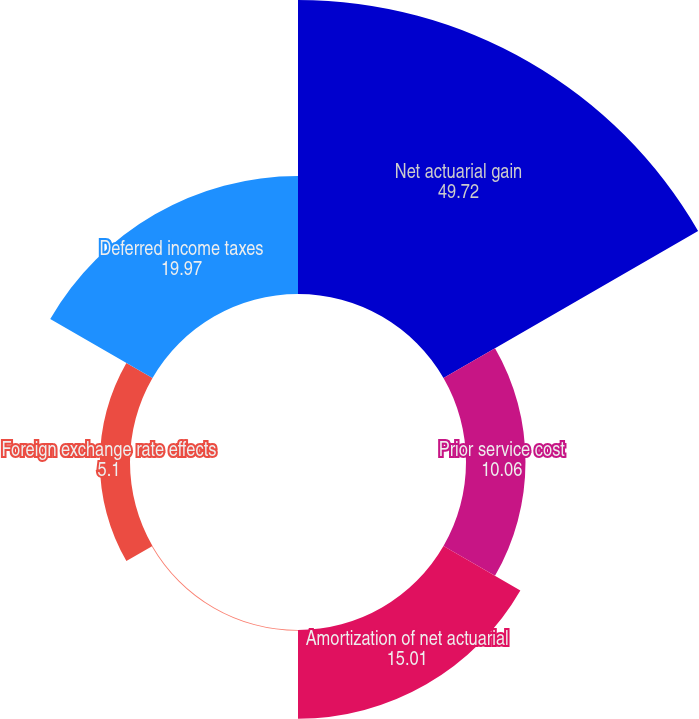<chart> <loc_0><loc_0><loc_500><loc_500><pie_chart><fcel>Net actuarial gain<fcel>Prior service cost<fcel>Amortization of net actuarial<fcel>Amortization of prior service<fcel>Foreign exchange rate effects<fcel>Deferred income taxes<nl><fcel>49.72%<fcel>10.06%<fcel>15.01%<fcel>0.14%<fcel>5.1%<fcel>19.97%<nl></chart> 